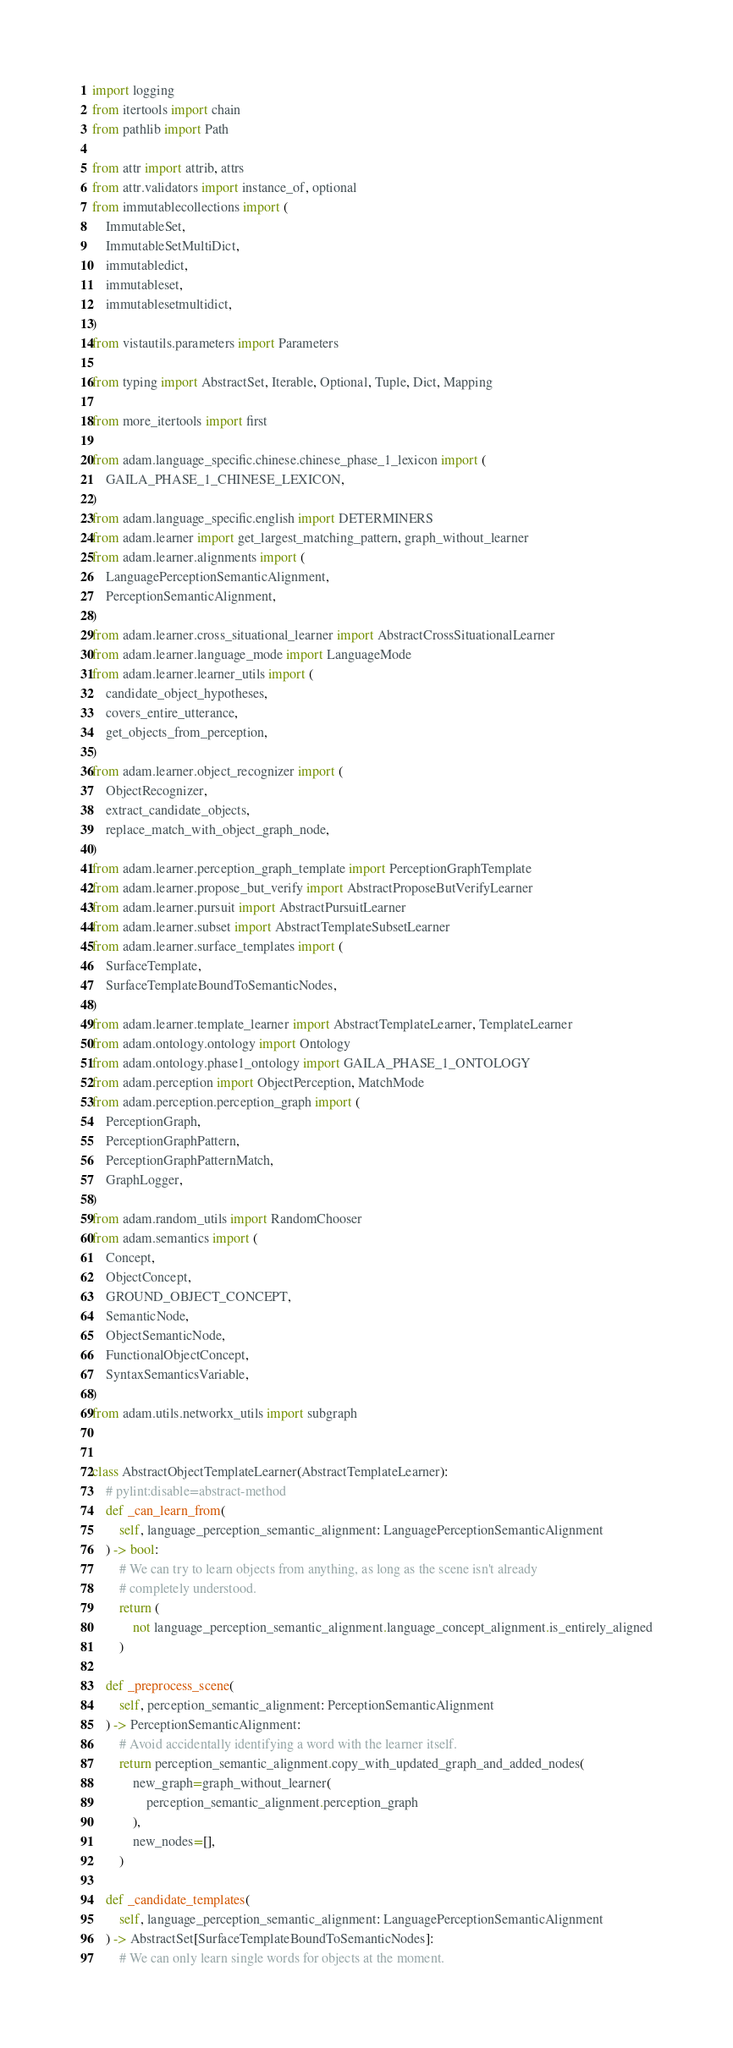Convert code to text. <code><loc_0><loc_0><loc_500><loc_500><_Python_>import logging
from itertools import chain
from pathlib import Path

from attr import attrib, attrs
from attr.validators import instance_of, optional
from immutablecollections import (
    ImmutableSet,
    ImmutableSetMultiDict,
    immutabledict,
    immutableset,
    immutablesetmultidict,
)
from vistautils.parameters import Parameters

from typing import AbstractSet, Iterable, Optional, Tuple, Dict, Mapping

from more_itertools import first

from adam.language_specific.chinese.chinese_phase_1_lexicon import (
    GAILA_PHASE_1_CHINESE_LEXICON,
)
from adam.language_specific.english import DETERMINERS
from adam.learner import get_largest_matching_pattern, graph_without_learner
from adam.learner.alignments import (
    LanguagePerceptionSemanticAlignment,
    PerceptionSemanticAlignment,
)
from adam.learner.cross_situational_learner import AbstractCrossSituationalLearner
from adam.learner.language_mode import LanguageMode
from adam.learner.learner_utils import (
    candidate_object_hypotheses,
    covers_entire_utterance,
    get_objects_from_perception,
)
from adam.learner.object_recognizer import (
    ObjectRecognizer,
    extract_candidate_objects,
    replace_match_with_object_graph_node,
)
from adam.learner.perception_graph_template import PerceptionGraphTemplate
from adam.learner.propose_but_verify import AbstractProposeButVerifyLearner
from adam.learner.pursuit import AbstractPursuitLearner
from adam.learner.subset import AbstractTemplateSubsetLearner
from adam.learner.surface_templates import (
    SurfaceTemplate,
    SurfaceTemplateBoundToSemanticNodes,
)
from adam.learner.template_learner import AbstractTemplateLearner, TemplateLearner
from adam.ontology.ontology import Ontology
from adam.ontology.phase1_ontology import GAILA_PHASE_1_ONTOLOGY
from adam.perception import ObjectPerception, MatchMode
from adam.perception.perception_graph import (
    PerceptionGraph,
    PerceptionGraphPattern,
    PerceptionGraphPatternMatch,
    GraphLogger,
)
from adam.random_utils import RandomChooser
from adam.semantics import (
    Concept,
    ObjectConcept,
    GROUND_OBJECT_CONCEPT,
    SemanticNode,
    ObjectSemanticNode,
    FunctionalObjectConcept,
    SyntaxSemanticsVariable,
)
from adam.utils.networkx_utils import subgraph


class AbstractObjectTemplateLearner(AbstractTemplateLearner):
    # pylint:disable=abstract-method
    def _can_learn_from(
        self, language_perception_semantic_alignment: LanguagePerceptionSemanticAlignment
    ) -> bool:
        # We can try to learn objects from anything, as long as the scene isn't already
        # completely understood.
        return (
            not language_perception_semantic_alignment.language_concept_alignment.is_entirely_aligned
        )

    def _preprocess_scene(
        self, perception_semantic_alignment: PerceptionSemanticAlignment
    ) -> PerceptionSemanticAlignment:
        # Avoid accidentally identifying a word with the learner itself.
        return perception_semantic_alignment.copy_with_updated_graph_and_added_nodes(
            new_graph=graph_without_learner(
                perception_semantic_alignment.perception_graph
            ),
            new_nodes=[],
        )

    def _candidate_templates(
        self, language_perception_semantic_alignment: LanguagePerceptionSemanticAlignment
    ) -> AbstractSet[SurfaceTemplateBoundToSemanticNodes]:
        # We can only learn single words for objects at the moment.</code> 